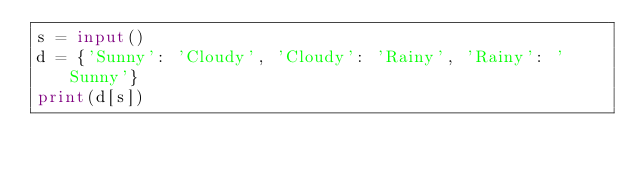Convert code to text. <code><loc_0><loc_0><loc_500><loc_500><_Python_>s = input()
d = {'Sunny': 'Cloudy', 'Cloudy': 'Rainy', 'Rainy': 'Sunny'}
print(d[s])</code> 